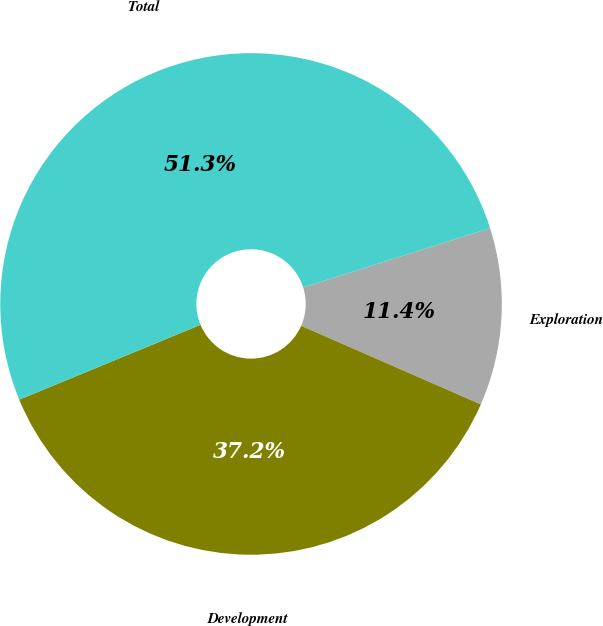Convert chart to OTSL. <chart><loc_0><loc_0><loc_500><loc_500><pie_chart><fcel>Exploration<fcel>Development<fcel>Total<nl><fcel>11.45%<fcel>37.21%<fcel>51.35%<nl></chart> 